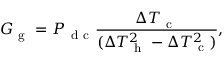<formula> <loc_0><loc_0><loc_500><loc_500>G _ { g } = P _ { d c } \frac { \Delta T _ { c } } { ( \Delta T _ { h } ^ { 2 } - \Delta T _ { c } ^ { 2 } ) } { , }</formula> 